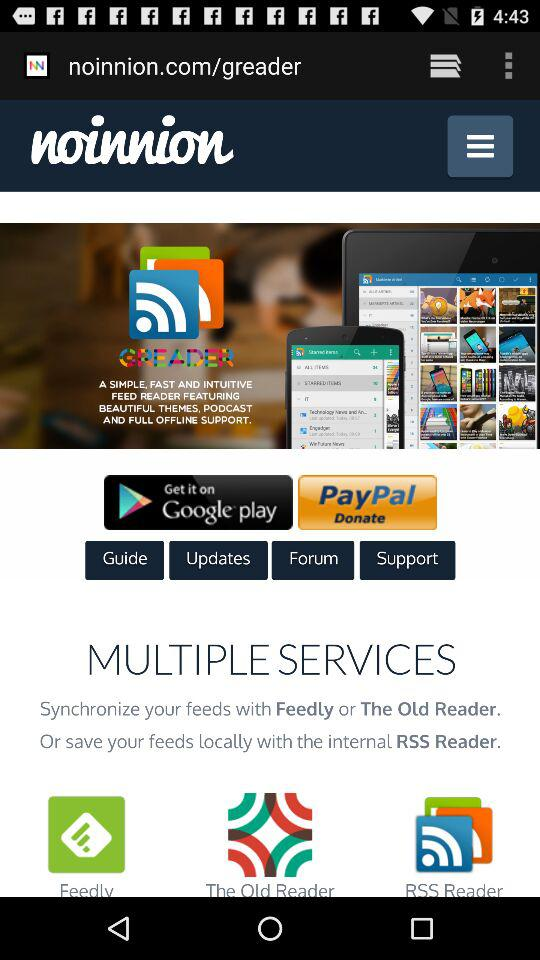How many services are supported by the app?
Answer the question using a single word or phrase. 3 